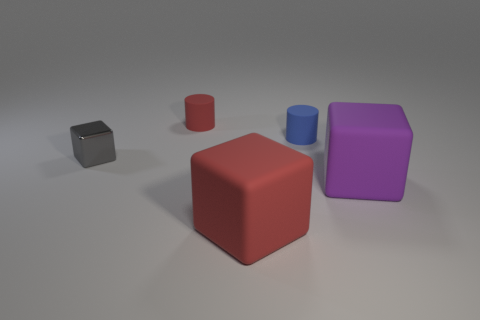Add 1 big cyan blocks. How many objects exist? 6 Subtract all cylinders. How many objects are left? 3 Add 4 big red rubber things. How many big red rubber things are left? 5 Add 3 large yellow balls. How many large yellow balls exist? 3 Subtract 0 green spheres. How many objects are left? 5 Subtract all big brown shiny cylinders. Subtract all small gray cubes. How many objects are left? 4 